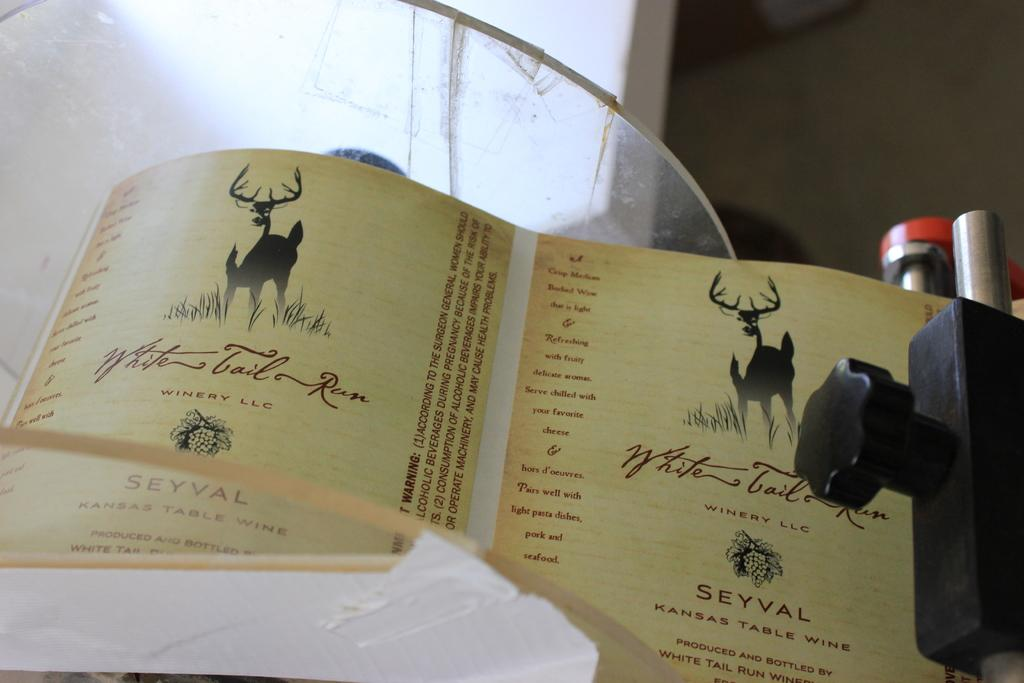Provide a one-sentence caption for the provided image. The name of the company depicted on the paper is called "Winery LLC.". 